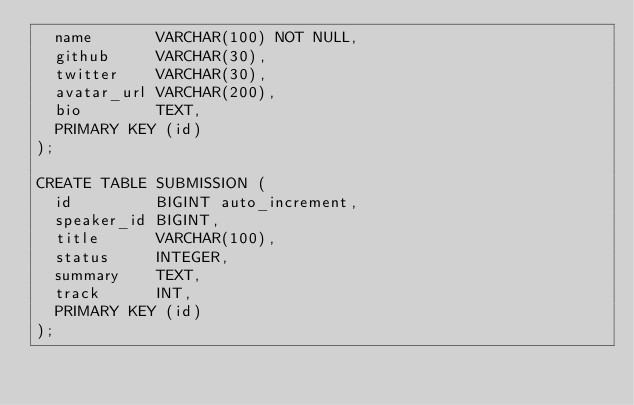Convert code to text. <code><loc_0><loc_0><loc_500><loc_500><_SQL_>  name       VARCHAR(100) NOT NULL,
  github     VARCHAR(30),
  twitter    VARCHAR(30),
  avatar_url VARCHAR(200),
  bio        TEXT,
  PRIMARY KEY (id)
);

CREATE TABLE SUBMISSION (
  id         BIGINT auto_increment,
  speaker_id BIGINT,
  title      VARCHAR(100),
  status     INTEGER,
  summary    TEXT,
  track      INT,
  PRIMARY KEY (id)
);</code> 